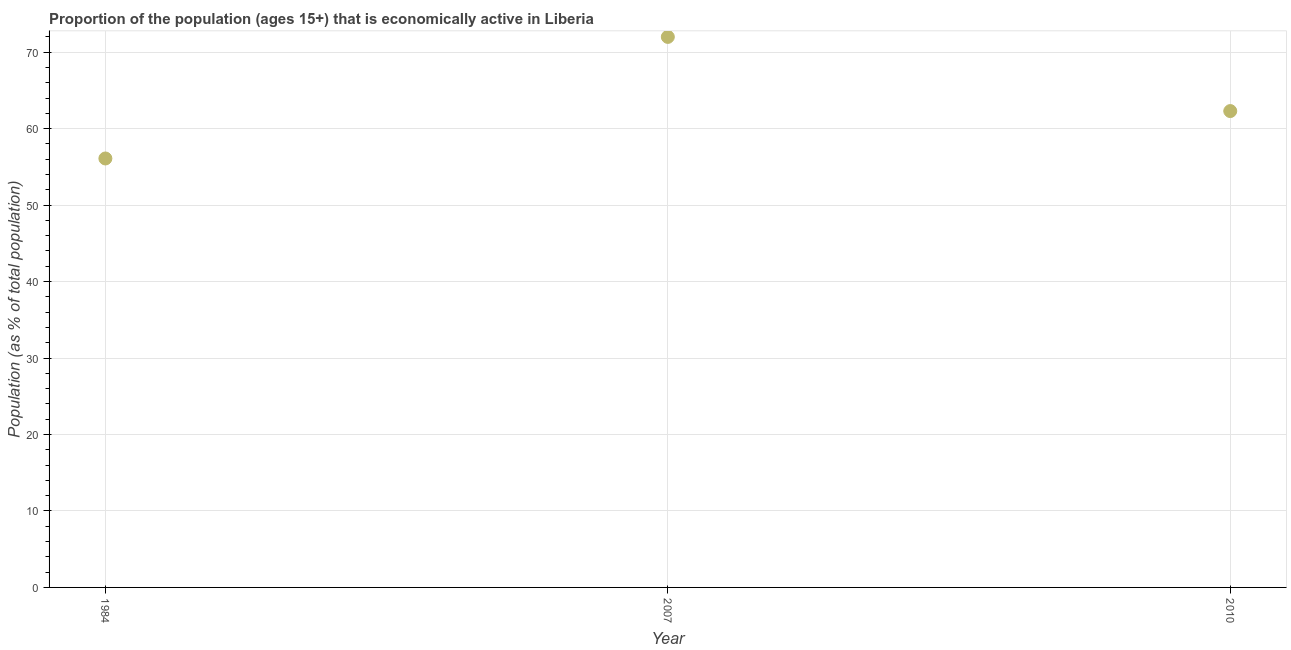Across all years, what is the minimum percentage of economically active population?
Ensure brevity in your answer.  56.1. In which year was the percentage of economically active population maximum?
Give a very brief answer. 2007. In which year was the percentage of economically active population minimum?
Offer a terse response. 1984. What is the sum of the percentage of economically active population?
Provide a succinct answer. 190.4. What is the difference between the percentage of economically active population in 1984 and 2007?
Provide a short and direct response. -15.9. What is the average percentage of economically active population per year?
Give a very brief answer. 63.47. What is the median percentage of economically active population?
Your answer should be compact. 62.3. In how many years, is the percentage of economically active population greater than 30 %?
Keep it short and to the point. 3. What is the ratio of the percentage of economically active population in 1984 to that in 2007?
Keep it short and to the point. 0.78. What is the difference between the highest and the second highest percentage of economically active population?
Offer a terse response. 9.7. Is the sum of the percentage of economically active population in 1984 and 2010 greater than the maximum percentage of economically active population across all years?
Ensure brevity in your answer.  Yes. What is the difference between the highest and the lowest percentage of economically active population?
Make the answer very short. 15.9. In how many years, is the percentage of economically active population greater than the average percentage of economically active population taken over all years?
Your answer should be compact. 1. How many dotlines are there?
Make the answer very short. 1. Does the graph contain any zero values?
Provide a short and direct response. No. Does the graph contain grids?
Provide a short and direct response. Yes. What is the title of the graph?
Offer a terse response. Proportion of the population (ages 15+) that is economically active in Liberia. What is the label or title of the X-axis?
Provide a short and direct response. Year. What is the label or title of the Y-axis?
Your answer should be compact. Population (as % of total population). What is the Population (as % of total population) in 1984?
Ensure brevity in your answer.  56.1. What is the Population (as % of total population) in 2007?
Your answer should be very brief. 72. What is the Population (as % of total population) in 2010?
Make the answer very short. 62.3. What is the difference between the Population (as % of total population) in 1984 and 2007?
Give a very brief answer. -15.9. What is the difference between the Population (as % of total population) in 2007 and 2010?
Offer a very short reply. 9.7. What is the ratio of the Population (as % of total population) in 1984 to that in 2007?
Ensure brevity in your answer.  0.78. What is the ratio of the Population (as % of total population) in 1984 to that in 2010?
Give a very brief answer. 0.9. What is the ratio of the Population (as % of total population) in 2007 to that in 2010?
Ensure brevity in your answer.  1.16. 